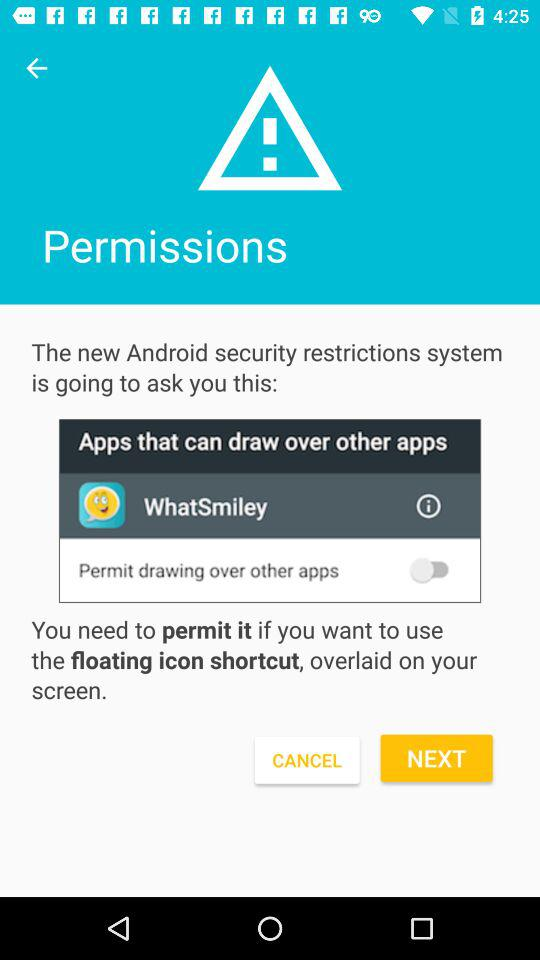What is the status of "Permit drawing over other apps"? The status is "off". 